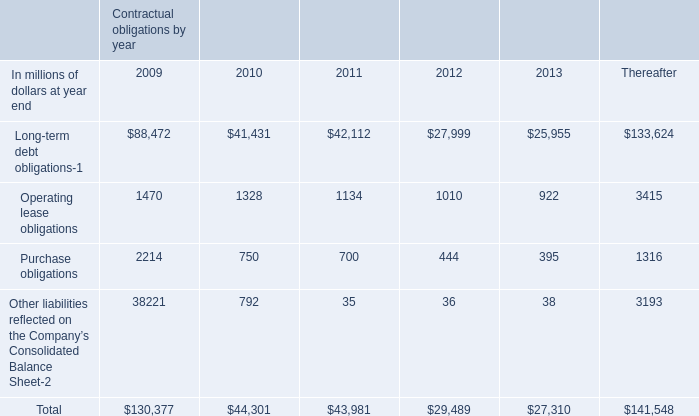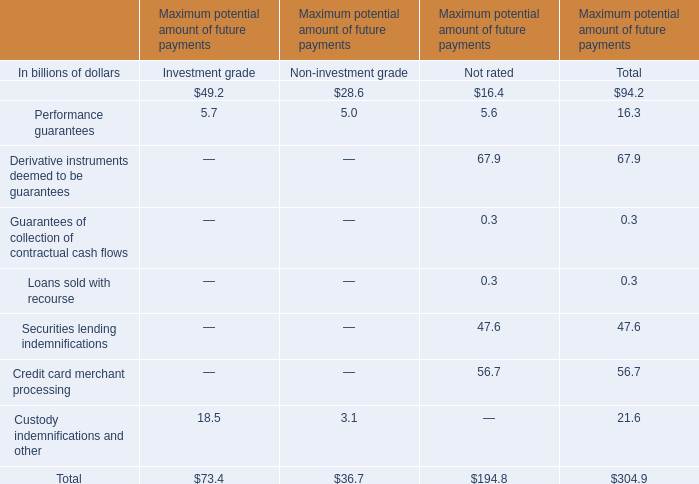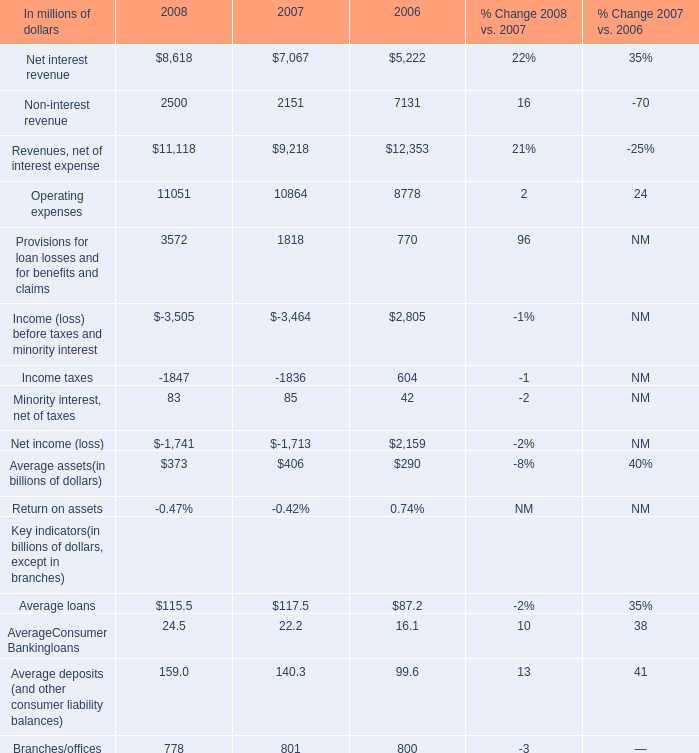What is the total value of Net interest revenue, Non-interest revenue, Revenues, net of interest expense and Operating expenses in 2008 ? (in million) 
Computations: (((8618 + 2500) + 11118) + 11051)
Answer: 33287.0. 